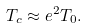<formula> <loc_0><loc_0><loc_500><loc_500>T _ { c } \approx e ^ { 2 } T _ { 0 } .</formula> 